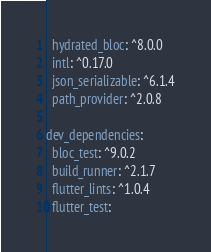<code> <loc_0><loc_0><loc_500><loc_500><_YAML_>  hydrated_bloc: ^8.0.0
  intl: ^0.17.0
  json_serializable: ^6.1.4
  path_provider: ^2.0.8

dev_dependencies:
  bloc_test: ^9.0.2
  build_runner: ^2.1.7
  flutter_lints: ^1.0.4
  flutter_test:</code> 